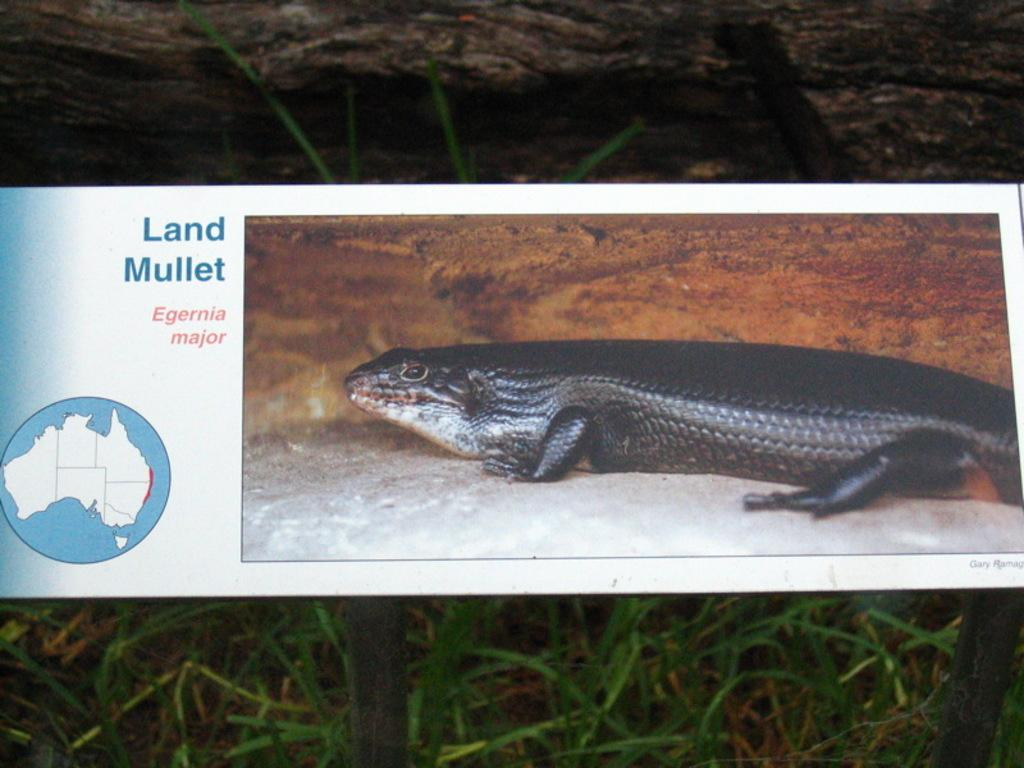What type of vegetation is present in the image? There is grass in the image. What type of object is made of wood in the image? There is a wooden trunk in the image. What is depicted on the board in the image? There is a board with an animal image in the image. What can be read on the board in the image? There is text written on the board. How does the force of the waves affect the grass in the image? There are no waves or water present in the image, so the force of waves cannot affect the grass. Is there a harbor visible in the image? No, there is no harbor present in the image. 